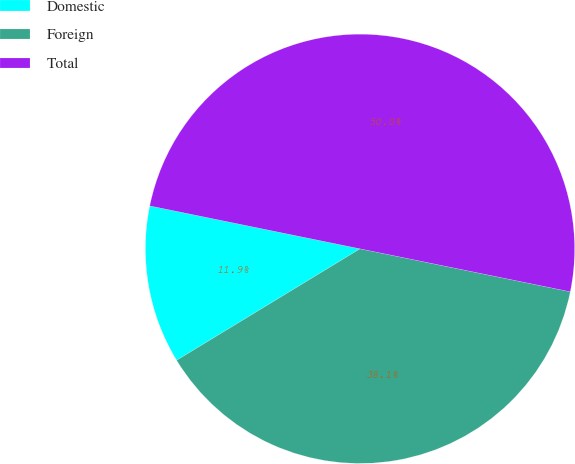Convert chart. <chart><loc_0><loc_0><loc_500><loc_500><pie_chart><fcel>Domestic<fcel>Foreign<fcel>Total<nl><fcel>11.9%<fcel>38.1%<fcel>50.0%<nl></chart> 